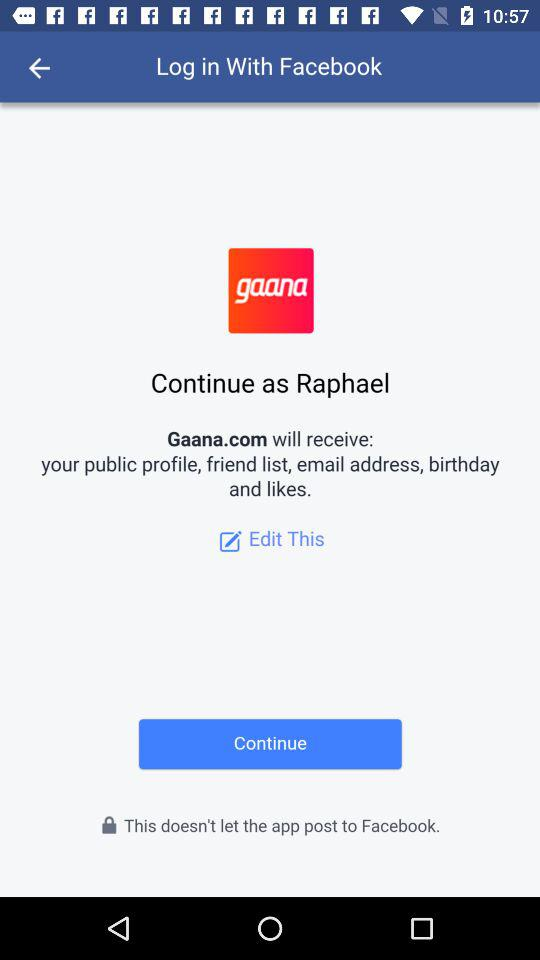What application will receive my public profile, friend list, email address, birthday, and likes? The application is "Gaana.com". 